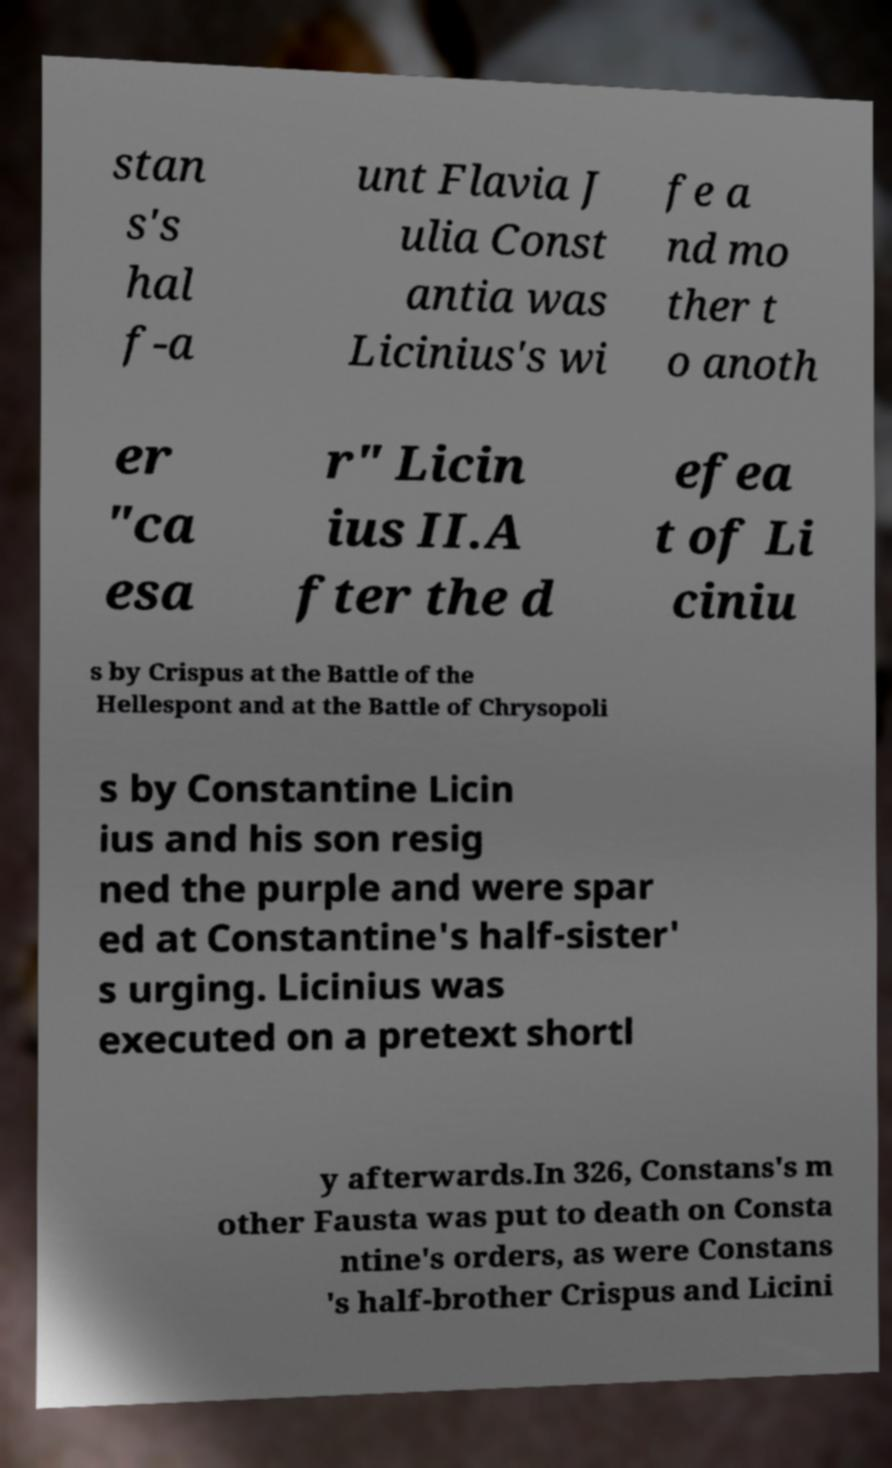Could you extract and type out the text from this image? stan s's hal f-a unt Flavia J ulia Const antia was Licinius's wi fe a nd mo ther t o anoth er "ca esa r" Licin ius II.A fter the d efea t of Li ciniu s by Crispus at the Battle of the Hellespont and at the Battle of Chrysopoli s by Constantine Licin ius and his son resig ned the purple and were spar ed at Constantine's half-sister' s urging. Licinius was executed on a pretext shortl y afterwards.In 326, Constans's m other Fausta was put to death on Consta ntine's orders, as were Constans 's half-brother Crispus and Licini 